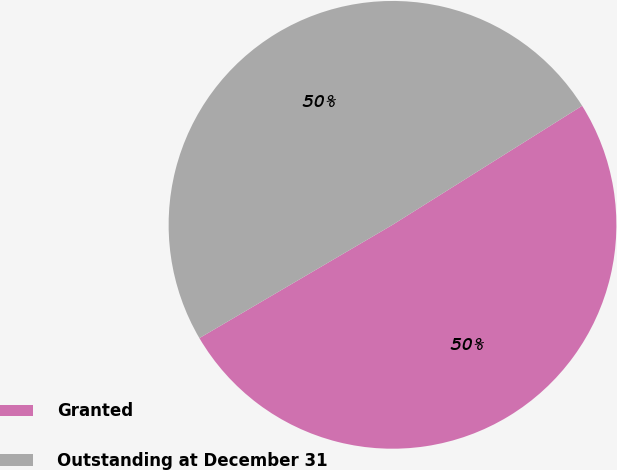Convert chart. <chart><loc_0><loc_0><loc_500><loc_500><pie_chart><fcel>Granted<fcel>Outstanding at December 31<nl><fcel>50.48%<fcel>49.52%<nl></chart> 